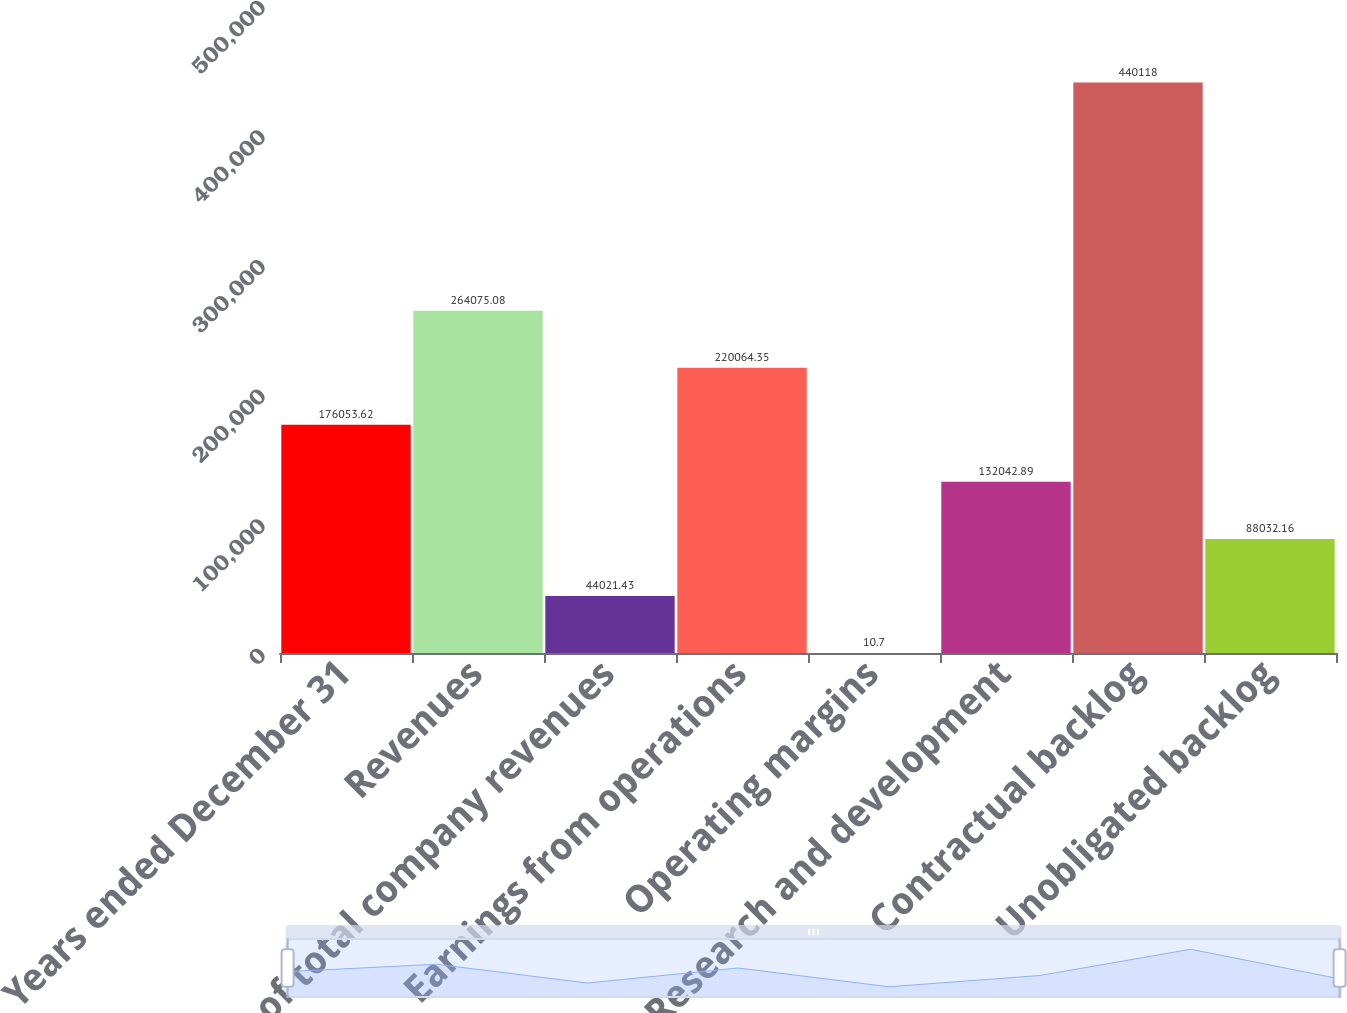<chart> <loc_0><loc_0><loc_500><loc_500><bar_chart><fcel>Years ended December 31<fcel>Revenues<fcel>of total company revenues<fcel>Earnings from operations<fcel>Operating margins<fcel>Research and development<fcel>Contractual backlog<fcel>Unobligated backlog<nl><fcel>176054<fcel>264075<fcel>44021.4<fcel>220064<fcel>10.7<fcel>132043<fcel>440118<fcel>88032.2<nl></chart> 